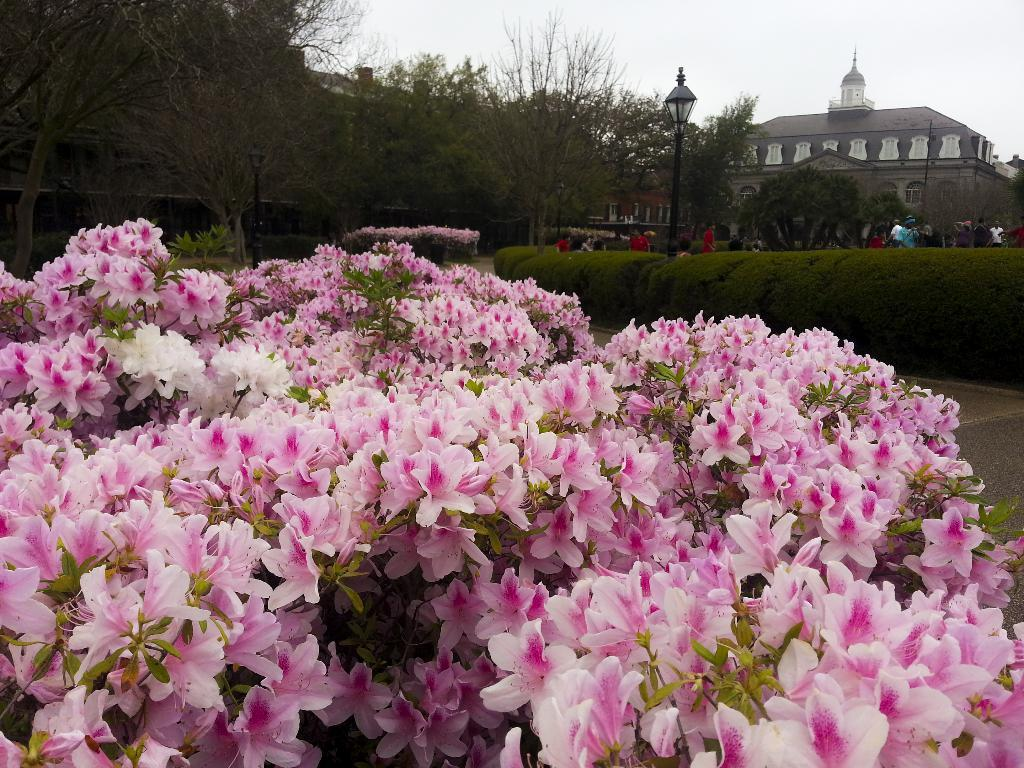What type of plants can be seen in the image? There are plants with flowers in the image. Can you describe the people in the image? There are people in the image, but their specific actions or appearances are not mentioned in the facts. What type of structures are visible in the image? Light poles and a building with windows are visible in the image. What type of vegetation is present in the image? Trees are present in the image. What is visible in the background of the image? The sky is visible in the background of the image. What type of cloth is being used to support the cable in the image? There is no mention of cloth or cable in the image; the facts only mention plants, people, light poles, trees, a building, and the sky. 